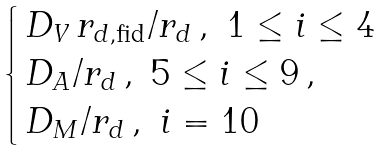Convert formula to latex. <formula><loc_0><loc_0><loc_500><loc_500>\begin{cases} \, D _ { V } \, r _ { d , \text {fid} } / r _ { d } \, , \ 1 \leq i \leq 4 \\ \, D _ { A } / r _ { d } \, , \ 5 \leq i \leq 9 \, , \\ \, D _ { M } / r _ { d } \, , \ i = 1 0 \end{cases}</formula> 